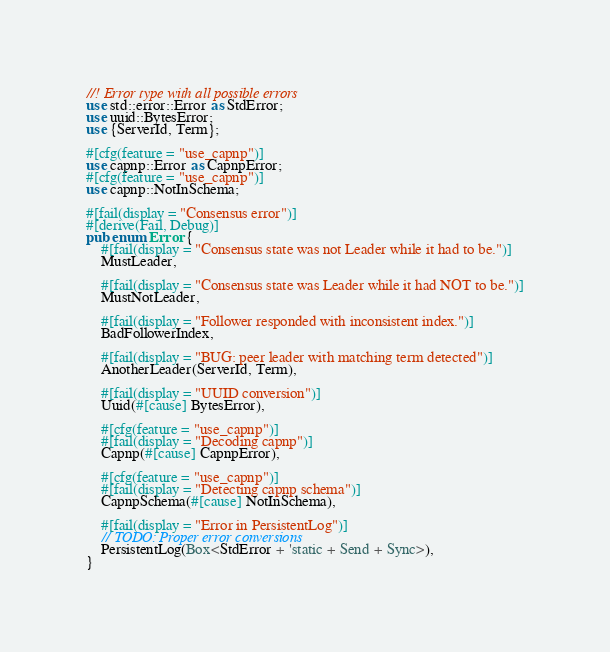<code> <loc_0><loc_0><loc_500><loc_500><_Rust_>//! Error type with all possible errors
use std::error::Error as StdError;
use uuid::BytesError;
use {ServerId, Term};

#[cfg(feature = "use_capnp")]
use capnp::Error as CapnpError;
#[cfg(feature = "use_capnp")]
use capnp::NotInSchema;

#[fail(display = "Consensus error")]
#[derive(Fail, Debug)]
pub enum Error {
    #[fail(display = "Consensus state was not Leader while it had to be.")]
    MustLeader,

    #[fail(display = "Consensus state was Leader while it had NOT to be.")]
    MustNotLeader,

    #[fail(display = "Follower responded with inconsistent index.")]
    BadFollowerIndex,

    #[fail(display = "BUG: peer leader with matching term detected")]
    AnotherLeader(ServerId, Term),

    #[fail(display = "UUID conversion")]
    Uuid(#[cause] BytesError),

    #[cfg(feature = "use_capnp")]
    #[fail(display = "Decoding capnp")]
    Capnp(#[cause] CapnpError),

    #[cfg(feature = "use_capnp")]
    #[fail(display = "Detecting capnp schema")]
    CapnpSchema(#[cause] NotInSchema),

    #[fail(display = "Error in PersistentLog")]
    // TODO: Proper error conversions
    PersistentLog(Box<StdError + 'static + Send + Sync>),
}
</code> 